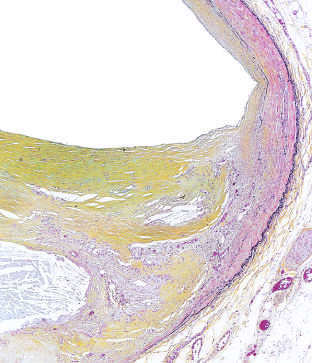re the available anabolic circuits attenuated?
Answer the question using a single word or phrase. No 